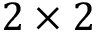Convert formula to latex. <formula><loc_0><loc_0><loc_500><loc_500>2 \times 2</formula> 